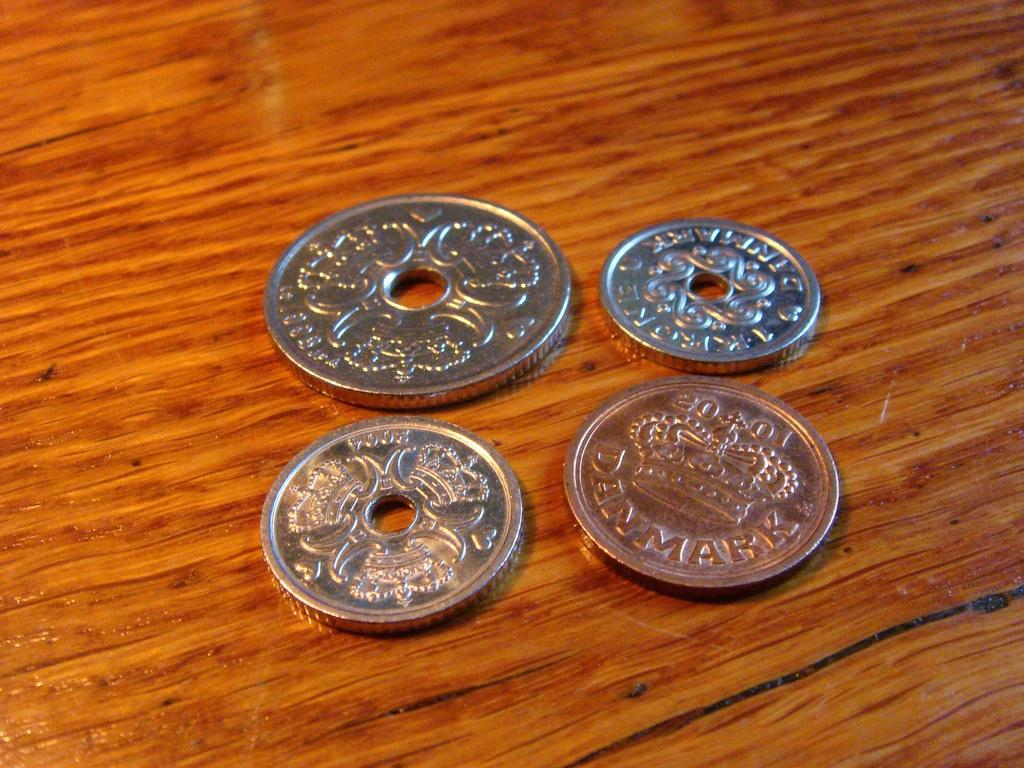<image>
Render a clear and concise summary of the photo. Four coins from Denmark sitting on a wood surface 